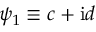Convert formula to latex. <formula><loc_0><loc_0><loc_500><loc_500>\psi _ { 1 } \equiv c + i d</formula> 